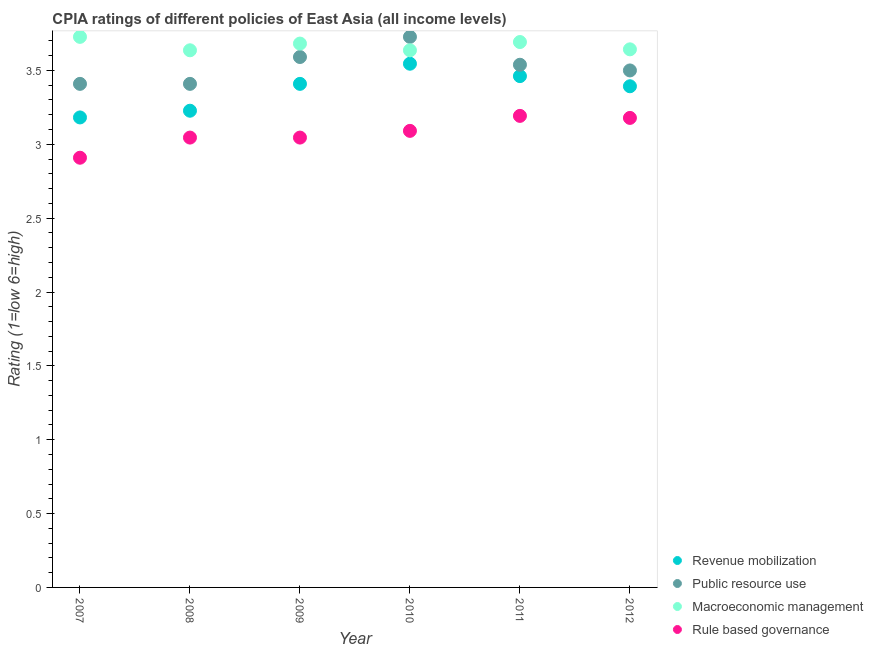How many different coloured dotlines are there?
Keep it short and to the point. 4. Across all years, what is the maximum cpia rating of revenue mobilization?
Ensure brevity in your answer.  3.55. Across all years, what is the minimum cpia rating of macroeconomic management?
Ensure brevity in your answer.  3.64. What is the total cpia rating of public resource use in the graph?
Your answer should be very brief. 21.17. What is the difference between the cpia rating of revenue mobilization in 2007 and that in 2010?
Provide a succinct answer. -0.36. What is the difference between the cpia rating of macroeconomic management in 2010 and the cpia rating of revenue mobilization in 2009?
Your answer should be compact. 0.23. What is the average cpia rating of rule based governance per year?
Ensure brevity in your answer.  3.08. In the year 2012, what is the difference between the cpia rating of rule based governance and cpia rating of macroeconomic management?
Ensure brevity in your answer.  -0.46. In how many years, is the cpia rating of rule based governance greater than 0.9?
Provide a short and direct response. 6. What is the ratio of the cpia rating of rule based governance in 2010 to that in 2011?
Keep it short and to the point. 0.97. Is the cpia rating of rule based governance in 2008 less than that in 2010?
Ensure brevity in your answer.  Yes. What is the difference between the highest and the second highest cpia rating of macroeconomic management?
Your answer should be very brief. 0.03. What is the difference between the highest and the lowest cpia rating of public resource use?
Offer a very short reply. 0.32. Is it the case that in every year, the sum of the cpia rating of rule based governance and cpia rating of revenue mobilization is greater than the sum of cpia rating of public resource use and cpia rating of macroeconomic management?
Provide a succinct answer. No. Is the cpia rating of public resource use strictly greater than the cpia rating of revenue mobilization over the years?
Give a very brief answer. Yes. Is the cpia rating of macroeconomic management strictly less than the cpia rating of revenue mobilization over the years?
Provide a short and direct response. No. How many dotlines are there?
Provide a succinct answer. 4. How many years are there in the graph?
Your answer should be very brief. 6. What is the difference between two consecutive major ticks on the Y-axis?
Give a very brief answer. 0.5. Does the graph contain any zero values?
Provide a succinct answer. No. Where does the legend appear in the graph?
Your answer should be compact. Bottom right. What is the title of the graph?
Make the answer very short. CPIA ratings of different policies of East Asia (all income levels). Does "Compensation of employees" appear as one of the legend labels in the graph?
Make the answer very short. No. What is the label or title of the X-axis?
Offer a very short reply. Year. What is the label or title of the Y-axis?
Give a very brief answer. Rating (1=low 6=high). What is the Rating (1=low 6=high) of Revenue mobilization in 2007?
Provide a succinct answer. 3.18. What is the Rating (1=low 6=high) of Public resource use in 2007?
Give a very brief answer. 3.41. What is the Rating (1=low 6=high) in Macroeconomic management in 2007?
Keep it short and to the point. 3.73. What is the Rating (1=low 6=high) in Rule based governance in 2007?
Offer a very short reply. 2.91. What is the Rating (1=low 6=high) in Revenue mobilization in 2008?
Keep it short and to the point. 3.23. What is the Rating (1=low 6=high) in Public resource use in 2008?
Your answer should be compact. 3.41. What is the Rating (1=low 6=high) in Macroeconomic management in 2008?
Provide a short and direct response. 3.64. What is the Rating (1=low 6=high) in Rule based governance in 2008?
Give a very brief answer. 3.05. What is the Rating (1=low 6=high) in Revenue mobilization in 2009?
Keep it short and to the point. 3.41. What is the Rating (1=low 6=high) in Public resource use in 2009?
Ensure brevity in your answer.  3.59. What is the Rating (1=low 6=high) of Macroeconomic management in 2009?
Give a very brief answer. 3.68. What is the Rating (1=low 6=high) of Rule based governance in 2009?
Make the answer very short. 3.05. What is the Rating (1=low 6=high) in Revenue mobilization in 2010?
Your answer should be very brief. 3.55. What is the Rating (1=low 6=high) in Public resource use in 2010?
Provide a short and direct response. 3.73. What is the Rating (1=low 6=high) of Macroeconomic management in 2010?
Give a very brief answer. 3.64. What is the Rating (1=low 6=high) of Rule based governance in 2010?
Make the answer very short. 3.09. What is the Rating (1=low 6=high) in Revenue mobilization in 2011?
Ensure brevity in your answer.  3.46. What is the Rating (1=low 6=high) in Public resource use in 2011?
Provide a short and direct response. 3.54. What is the Rating (1=low 6=high) in Macroeconomic management in 2011?
Offer a terse response. 3.69. What is the Rating (1=low 6=high) of Rule based governance in 2011?
Your answer should be very brief. 3.19. What is the Rating (1=low 6=high) of Revenue mobilization in 2012?
Provide a succinct answer. 3.39. What is the Rating (1=low 6=high) in Macroeconomic management in 2012?
Your answer should be compact. 3.64. What is the Rating (1=low 6=high) in Rule based governance in 2012?
Provide a short and direct response. 3.18. Across all years, what is the maximum Rating (1=low 6=high) of Revenue mobilization?
Your answer should be compact. 3.55. Across all years, what is the maximum Rating (1=low 6=high) in Public resource use?
Give a very brief answer. 3.73. Across all years, what is the maximum Rating (1=low 6=high) in Macroeconomic management?
Provide a succinct answer. 3.73. Across all years, what is the maximum Rating (1=low 6=high) in Rule based governance?
Keep it short and to the point. 3.19. Across all years, what is the minimum Rating (1=low 6=high) of Revenue mobilization?
Provide a short and direct response. 3.18. Across all years, what is the minimum Rating (1=low 6=high) of Public resource use?
Offer a very short reply. 3.41. Across all years, what is the minimum Rating (1=low 6=high) of Macroeconomic management?
Give a very brief answer. 3.64. Across all years, what is the minimum Rating (1=low 6=high) in Rule based governance?
Offer a very short reply. 2.91. What is the total Rating (1=low 6=high) of Revenue mobilization in the graph?
Make the answer very short. 20.22. What is the total Rating (1=low 6=high) in Public resource use in the graph?
Your answer should be very brief. 21.17. What is the total Rating (1=low 6=high) in Macroeconomic management in the graph?
Your answer should be very brief. 22.02. What is the total Rating (1=low 6=high) of Rule based governance in the graph?
Your response must be concise. 18.46. What is the difference between the Rating (1=low 6=high) in Revenue mobilization in 2007 and that in 2008?
Provide a short and direct response. -0.05. What is the difference between the Rating (1=low 6=high) in Public resource use in 2007 and that in 2008?
Make the answer very short. 0. What is the difference between the Rating (1=low 6=high) in Macroeconomic management in 2007 and that in 2008?
Your answer should be compact. 0.09. What is the difference between the Rating (1=low 6=high) in Rule based governance in 2007 and that in 2008?
Your response must be concise. -0.14. What is the difference between the Rating (1=low 6=high) of Revenue mobilization in 2007 and that in 2009?
Provide a short and direct response. -0.23. What is the difference between the Rating (1=low 6=high) in Public resource use in 2007 and that in 2009?
Your response must be concise. -0.18. What is the difference between the Rating (1=low 6=high) in Macroeconomic management in 2007 and that in 2009?
Your answer should be very brief. 0.05. What is the difference between the Rating (1=low 6=high) in Rule based governance in 2007 and that in 2009?
Your answer should be compact. -0.14. What is the difference between the Rating (1=low 6=high) of Revenue mobilization in 2007 and that in 2010?
Offer a very short reply. -0.36. What is the difference between the Rating (1=low 6=high) in Public resource use in 2007 and that in 2010?
Ensure brevity in your answer.  -0.32. What is the difference between the Rating (1=low 6=high) of Macroeconomic management in 2007 and that in 2010?
Offer a very short reply. 0.09. What is the difference between the Rating (1=low 6=high) of Rule based governance in 2007 and that in 2010?
Your answer should be compact. -0.18. What is the difference between the Rating (1=low 6=high) in Revenue mobilization in 2007 and that in 2011?
Give a very brief answer. -0.28. What is the difference between the Rating (1=low 6=high) of Public resource use in 2007 and that in 2011?
Your response must be concise. -0.13. What is the difference between the Rating (1=low 6=high) in Macroeconomic management in 2007 and that in 2011?
Your answer should be very brief. 0.04. What is the difference between the Rating (1=low 6=high) of Rule based governance in 2007 and that in 2011?
Offer a terse response. -0.28. What is the difference between the Rating (1=low 6=high) in Revenue mobilization in 2007 and that in 2012?
Give a very brief answer. -0.21. What is the difference between the Rating (1=low 6=high) of Public resource use in 2007 and that in 2012?
Make the answer very short. -0.09. What is the difference between the Rating (1=low 6=high) of Macroeconomic management in 2007 and that in 2012?
Give a very brief answer. 0.08. What is the difference between the Rating (1=low 6=high) of Rule based governance in 2007 and that in 2012?
Keep it short and to the point. -0.27. What is the difference between the Rating (1=low 6=high) in Revenue mobilization in 2008 and that in 2009?
Your answer should be very brief. -0.18. What is the difference between the Rating (1=low 6=high) in Public resource use in 2008 and that in 2009?
Make the answer very short. -0.18. What is the difference between the Rating (1=low 6=high) in Macroeconomic management in 2008 and that in 2009?
Provide a succinct answer. -0.05. What is the difference between the Rating (1=low 6=high) of Rule based governance in 2008 and that in 2009?
Your response must be concise. 0. What is the difference between the Rating (1=low 6=high) of Revenue mobilization in 2008 and that in 2010?
Your answer should be very brief. -0.32. What is the difference between the Rating (1=low 6=high) in Public resource use in 2008 and that in 2010?
Your response must be concise. -0.32. What is the difference between the Rating (1=low 6=high) in Rule based governance in 2008 and that in 2010?
Keep it short and to the point. -0.05. What is the difference between the Rating (1=low 6=high) in Revenue mobilization in 2008 and that in 2011?
Your answer should be compact. -0.23. What is the difference between the Rating (1=low 6=high) in Public resource use in 2008 and that in 2011?
Give a very brief answer. -0.13. What is the difference between the Rating (1=low 6=high) in Macroeconomic management in 2008 and that in 2011?
Offer a very short reply. -0.06. What is the difference between the Rating (1=low 6=high) of Rule based governance in 2008 and that in 2011?
Your answer should be compact. -0.15. What is the difference between the Rating (1=low 6=high) in Revenue mobilization in 2008 and that in 2012?
Your response must be concise. -0.17. What is the difference between the Rating (1=low 6=high) of Public resource use in 2008 and that in 2012?
Provide a short and direct response. -0.09. What is the difference between the Rating (1=low 6=high) of Macroeconomic management in 2008 and that in 2012?
Give a very brief answer. -0.01. What is the difference between the Rating (1=low 6=high) of Rule based governance in 2008 and that in 2012?
Ensure brevity in your answer.  -0.13. What is the difference between the Rating (1=low 6=high) in Revenue mobilization in 2009 and that in 2010?
Your response must be concise. -0.14. What is the difference between the Rating (1=low 6=high) of Public resource use in 2009 and that in 2010?
Provide a short and direct response. -0.14. What is the difference between the Rating (1=low 6=high) in Macroeconomic management in 2009 and that in 2010?
Keep it short and to the point. 0.05. What is the difference between the Rating (1=low 6=high) of Rule based governance in 2009 and that in 2010?
Ensure brevity in your answer.  -0.05. What is the difference between the Rating (1=low 6=high) in Revenue mobilization in 2009 and that in 2011?
Ensure brevity in your answer.  -0.05. What is the difference between the Rating (1=low 6=high) in Public resource use in 2009 and that in 2011?
Make the answer very short. 0.05. What is the difference between the Rating (1=low 6=high) of Macroeconomic management in 2009 and that in 2011?
Provide a short and direct response. -0.01. What is the difference between the Rating (1=low 6=high) of Rule based governance in 2009 and that in 2011?
Your response must be concise. -0.15. What is the difference between the Rating (1=low 6=high) in Revenue mobilization in 2009 and that in 2012?
Offer a terse response. 0.02. What is the difference between the Rating (1=low 6=high) in Public resource use in 2009 and that in 2012?
Provide a succinct answer. 0.09. What is the difference between the Rating (1=low 6=high) of Macroeconomic management in 2009 and that in 2012?
Your answer should be very brief. 0.04. What is the difference between the Rating (1=low 6=high) in Rule based governance in 2009 and that in 2012?
Provide a succinct answer. -0.13. What is the difference between the Rating (1=low 6=high) of Revenue mobilization in 2010 and that in 2011?
Offer a terse response. 0.08. What is the difference between the Rating (1=low 6=high) in Public resource use in 2010 and that in 2011?
Ensure brevity in your answer.  0.19. What is the difference between the Rating (1=low 6=high) of Macroeconomic management in 2010 and that in 2011?
Ensure brevity in your answer.  -0.06. What is the difference between the Rating (1=low 6=high) of Rule based governance in 2010 and that in 2011?
Provide a short and direct response. -0.1. What is the difference between the Rating (1=low 6=high) of Revenue mobilization in 2010 and that in 2012?
Keep it short and to the point. 0.15. What is the difference between the Rating (1=low 6=high) in Public resource use in 2010 and that in 2012?
Your answer should be compact. 0.23. What is the difference between the Rating (1=low 6=high) in Macroeconomic management in 2010 and that in 2012?
Your answer should be compact. -0.01. What is the difference between the Rating (1=low 6=high) in Rule based governance in 2010 and that in 2012?
Your response must be concise. -0.09. What is the difference between the Rating (1=low 6=high) in Revenue mobilization in 2011 and that in 2012?
Provide a succinct answer. 0.07. What is the difference between the Rating (1=low 6=high) in Public resource use in 2011 and that in 2012?
Your answer should be compact. 0.04. What is the difference between the Rating (1=low 6=high) of Macroeconomic management in 2011 and that in 2012?
Provide a succinct answer. 0.05. What is the difference between the Rating (1=low 6=high) of Rule based governance in 2011 and that in 2012?
Offer a terse response. 0.01. What is the difference between the Rating (1=low 6=high) of Revenue mobilization in 2007 and the Rating (1=low 6=high) of Public resource use in 2008?
Make the answer very short. -0.23. What is the difference between the Rating (1=low 6=high) of Revenue mobilization in 2007 and the Rating (1=low 6=high) of Macroeconomic management in 2008?
Your answer should be very brief. -0.45. What is the difference between the Rating (1=low 6=high) of Revenue mobilization in 2007 and the Rating (1=low 6=high) of Rule based governance in 2008?
Your answer should be compact. 0.14. What is the difference between the Rating (1=low 6=high) in Public resource use in 2007 and the Rating (1=low 6=high) in Macroeconomic management in 2008?
Your answer should be very brief. -0.23. What is the difference between the Rating (1=low 6=high) in Public resource use in 2007 and the Rating (1=low 6=high) in Rule based governance in 2008?
Keep it short and to the point. 0.36. What is the difference between the Rating (1=low 6=high) of Macroeconomic management in 2007 and the Rating (1=low 6=high) of Rule based governance in 2008?
Offer a terse response. 0.68. What is the difference between the Rating (1=low 6=high) in Revenue mobilization in 2007 and the Rating (1=low 6=high) in Public resource use in 2009?
Ensure brevity in your answer.  -0.41. What is the difference between the Rating (1=low 6=high) in Revenue mobilization in 2007 and the Rating (1=low 6=high) in Macroeconomic management in 2009?
Give a very brief answer. -0.5. What is the difference between the Rating (1=low 6=high) of Revenue mobilization in 2007 and the Rating (1=low 6=high) of Rule based governance in 2009?
Ensure brevity in your answer.  0.14. What is the difference between the Rating (1=low 6=high) in Public resource use in 2007 and the Rating (1=low 6=high) in Macroeconomic management in 2009?
Your answer should be very brief. -0.27. What is the difference between the Rating (1=low 6=high) of Public resource use in 2007 and the Rating (1=low 6=high) of Rule based governance in 2009?
Ensure brevity in your answer.  0.36. What is the difference between the Rating (1=low 6=high) of Macroeconomic management in 2007 and the Rating (1=low 6=high) of Rule based governance in 2009?
Your response must be concise. 0.68. What is the difference between the Rating (1=low 6=high) in Revenue mobilization in 2007 and the Rating (1=low 6=high) in Public resource use in 2010?
Your answer should be compact. -0.55. What is the difference between the Rating (1=low 6=high) of Revenue mobilization in 2007 and the Rating (1=low 6=high) of Macroeconomic management in 2010?
Ensure brevity in your answer.  -0.45. What is the difference between the Rating (1=low 6=high) of Revenue mobilization in 2007 and the Rating (1=low 6=high) of Rule based governance in 2010?
Make the answer very short. 0.09. What is the difference between the Rating (1=low 6=high) of Public resource use in 2007 and the Rating (1=low 6=high) of Macroeconomic management in 2010?
Provide a short and direct response. -0.23. What is the difference between the Rating (1=low 6=high) in Public resource use in 2007 and the Rating (1=low 6=high) in Rule based governance in 2010?
Provide a short and direct response. 0.32. What is the difference between the Rating (1=low 6=high) of Macroeconomic management in 2007 and the Rating (1=low 6=high) of Rule based governance in 2010?
Ensure brevity in your answer.  0.64. What is the difference between the Rating (1=low 6=high) of Revenue mobilization in 2007 and the Rating (1=low 6=high) of Public resource use in 2011?
Offer a very short reply. -0.36. What is the difference between the Rating (1=low 6=high) of Revenue mobilization in 2007 and the Rating (1=low 6=high) of Macroeconomic management in 2011?
Provide a succinct answer. -0.51. What is the difference between the Rating (1=low 6=high) of Revenue mobilization in 2007 and the Rating (1=low 6=high) of Rule based governance in 2011?
Make the answer very short. -0.01. What is the difference between the Rating (1=low 6=high) in Public resource use in 2007 and the Rating (1=low 6=high) in Macroeconomic management in 2011?
Offer a very short reply. -0.28. What is the difference between the Rating (1=low 6=high) in Public resource use in 2007 and the Rating (1=low 6=high) in Rule based governance in 2011?
Your response must be concise. 0.22. What is the difference between the Rating (1=low 6=high) in Macroeconomic management in 2007 and the Rating (1=low 6=high) in Rule based governance in 2011?
Provide a succinct answer. 0.54. What is the difference between the Rating (1=low 6=high) of Revenue mobilization in 2007 and the Rating (1=low 6=high) of Public resource use in 2012?
Provide a short and direct response. -0.32. What is the difference between the Rating (1=low 6=high) in Revenue mobilization in 2007 and the Rating (1=low 6=high) in Macroeconomic management in 2012?
Ensure brevity in your answer.  -0.46. What is the difference between the Rating (1=low 6=high) in Revenue mobilization in 2007 and the Rating (1=low 6=high) in Rule based governance in 2012?
Your answer should be compact. 0. What is the difference between the Rating (1=low 6=high) in Public resource use in 2007 and the Rating (1=low 6=high) in Macroeconomic management in 2012?
Give a very brief answer. -0.23. What is the difference between the Rating (1=low 6=high) in Public resource use in 2007 and the Rating (1=low 6=high) in Rule based governance in 2012?
Ensure brevity in your answer.  0.23. What is the difference between the Rating (1=low 6=high) in Macroeconomic management in 2007 and the Rating (1=low 6=high) in Rule based governance in 2012?
Provide a succinct answer. 0.55. What is the difference between the Rating (1=low 6=high) of Revenue mobilization in 2008 and the Rating (1=low 6=high) of Public resource use in 2009?
Make the answer very short. -0.36. What is the difference between the Rating (1=low 6=high) of Revenue mobilization in 2008 and the Rating (1=low 6=high) of Macroeconomic management in 2009?
Keep it short and to the point. -0.45. What is the difference between the Rating (1=low 6=high) of Revenue mobilization in 2008 and the Rating (1=low 6=high) of Rule based governance in 2009?
Your answer should be very brief. 0.18. What is the difference between the Rating (1=low 6=high) of Public resource use in 2008 and the Rating (1=low 6=high) of Macroeconomic management in 2009?
Keep it short and to the point. -0.27. What is the difference between the Rating (1=low 6=high) of Public resource use in 2008 and the Rating (1=low 6=high) of Rule based governance in 2009?
Offer a very short reply. 0.36. What is the difference between the Rating (1=low 6=high) of Macroeconomic management in 2008 and the Rating (1=low 6=high) of Rule based governance in 2009?
Your response must be concise. 0.59. What is the difference between the Rating (1=low 6=high) of Revenue mobilization in 2008 and the Rating (1=low 6=high) of Macroeconomic management in 2010?
Ensure brevity in your answer.  -0.41. What is the difference between the Rating (1=low 6=high) of Revenue mobilization in 2008 and the Rating (1=low 6=high) of Rule based governance in 2010?
Your answer should be compact. 0.14. What is the difference between the Rating (1=low 6=high) in Public resource use in 2008 and the Rating (1=low 6=high) in Macroeconomic management in 2010?
Offer a terse response. -0.23. What is the difference between the Rating (1=low 6=high) of Public resource use in 2008 and the Rating (1=low 6=high) of Rule based governance in 2010?
Your answer should be compact. 0.32. What is the difference between the Rating (1=low 6=high) of Macroeconomic management in 2008 and the Rating (1=low 6=high) of Rule based governance in 2010?
Make the answer very short. 0.55. What is the difference between the Rating (1=low 6=high) of Revenue mobilization in 2008 and the Rating (1=low 6=high) of Public resource use in 2011?
Give a very brief answer. -0.31. What is the difference between the Rating (1=low 6=high) of Revenue mobilization in 2008 and the Rating (1=low 6=high) of Macroeconomic management in 2011?
Make the answer very short. -0.47. What is the difference between the Rating (1=low 6=high) of Revenue mobilization in 2008 and the Rating (1=low 6=high) of Rule based governance in 2011?
Ensure brevity in your answer.  0.04. What is the difference between the Rating (1=low 6=high) in Public resource use in 2008 and the Rating (1=low 6=high) in Macroeconomic management in 2011?
Provide a succinct answer. -0.28. What is the difference between the Rating (1=low 6=high) in Public resource use in 2008 and the Rating (1=low 6=high) in Rule based governance in 2011?
Keep it short and to the point. 0.22. What is the difference between the Rating (1=low 6=high) in Macroeconomic management in 2008 and the Rating (1=low 6=high) in Rule based governance in 2011?
Offer a very short reply. 0.44. What is the difference between the Rating (1=low 6=high) of Revenue mobilization in 2008 and the Rating (1=low 6=high) of Public resource use in 2012?
Your answer should be compact. -0.27. What is the difference between the Rating (1=low 6=high) of Revenue mobilization in 2008 and the Rating (1=low 6=high) of Macroeconomic management in 2012?
Your response must be concise. -0.42. What is the difference between the Rating (1=low 6=high) of Revenue mobilization in 2008 and the Rating (1=low 6=high) of Rule based governance in 2012?
Your answer should be compact. 0.05. What is the difference between the Rating (1=low 6=high) in Public resource use in 2008 and the Rating (1=low 6=high) in Macroeconomic management in 2012?
Your answer should be compact. -0.23. What is the difference between the Rating (1=low 6=high) in Public resource use in 2008 and the Rating (1=low 6=high) in Rule based governance in 2012?
Offer a terse response. 0.23. What is the difference between the Rating (1=low 6=high) of Macroeconomic management in 2008 and the Rating (1=low 6=high) of Rule based governance in 2012?
Keep it short and to the point. 0.46. What is the difference between the Rating (1=low 6=high) in Revenue mobilization in 2009 and the Rating (1=low 6=high) in Public resource use in 2010?
Your answer should be very brief. -0.32. What is the difference between the Rating (1=low 6=high) in Revenue mobilization in 2009 and the Rating (1=low 6=high) in Macroeconomic management in 2010?
Make the answer very short. -0.23. What is the difference between the Rating (1=low 6=high) in Revenue mobilization in 2009 and the Rating (1=low 6=high) in Rule based governance in 2010?
Offer a terse response. 0.32. What is the difference between the Rating (1=low 6=high) in Public resource use in 2009 and the Rating (1=low 6=high) in Macroeconomic management in 2010?
Make the answer very short. -0.05. What is the difference between the Rating (1=low 6=high) in Macroeconomic management in 2009 and the Rating (1=low 6=high) in Rule based governance in 2010?
Your answer should be compact. 0.59. What is the difference between the Rating (1=low 6=high) in Revenue mobilization in 2009 and the Rating (1=low 6=high) in Public resource use in 2011?
Your answer should be compact. -0.13. What is the difference between the Rating (1=low 6=high) of Revenue mobilization in 2009 and the Rating (1=low 6=high) of Macroeconomic management in 2011?
Your response must be concise. -0.28. What is the difference between the Rating (1=low 6=high) in Revenue mobilization in 2009 and the Rating (1=low 6=high) in Rule based governance in 2011?
Your answer should be compact. 0.22. What is the difference between the Rating (1=low 6=high) in Public resource use in 2009 and the Rating (1=low 6=high) in Macroeconomic management in 2011?
Keep it short and to the point. -0.1. What is the difference between the Rating (1=low 6=high) in Public resource use in 2009 and the Rating (1=low 6=high) in Rule based governance in 2011?
Provide a succinct answer. 0.4. What is the difference between the Rating (1=low 6=high) in Macroeconomic management in 2009 and the Rating (1=low 6=high) in Rule based governance in 2011?
Ensure brevity in your answer.  0.49. What is the difference between the Rating (1=low 6=high) of Revenue mobilization in 2009 and the Rating (1=low 6=high) of Public resource use in 2012?
Offer a very short reply. -0.09. What is the difference between the Rating (1=low 6=high) in Revenue mobilization in 2009 and the Rating (1=low 6=high) in Macroeconomic management in 2012?
Give a very brief answer. -0.23. What is the difference between the Rating (1=low 6=high) in Revenue mobilization in 2009 and the Rating (1=low 6=high) in Rule based governance in 2012?
Make the answer very short. 0.23. What is the difference between the Rating (1=low 6=high) in Public resource use in 2009 and the Rating (1=low 6=high) in Macroeconomic management in 2012?
Make the answer very short. -0.05. What is the difference between the Rating (1=low 6=high) in Public resource use in 2009 and the Rating (1=low 6=high) in Rule based governance in 2012?
Provide a succinct answer. 0.41. What is the difference between the Rating (1=low 6=high) of Macroeconomic management in 2009 and the Rating (1=low 6=high) of Rule based governance in 2012?
Your answer should be very brief. 0.5. What is the difference between the Rating (1=low 6=high) in Revenue mobilization in 2010 and the Rating (1=low 6=high) in Public resource use in 2011?
Offer a very short reply. 0.01. What is the difference between the Rating (1=low 6=high) of Revenue mobilization in 2010 and the Rating (1=low 6=high) of Macroeconomic management in 2011?
Offer a terse response. -0.15. What is the difference between the Rating (1=low 6=high) in Revenue mobilization in 2010 and the Rating (1=low 6=high) in Rule based governance in 2011?
Ensure brevity in your answer.  0.35. What is the difference between the Rating (1=low 6=high) of Public resource use in 2010 and the Rating (1=low 6=high) of Macroeconomic management in 2011?
Keep it short and to the point. 0.04. What is the difference between the Rating (1=low 6=high) in Public resource use in 2010 and the Rating (1=low 6=high) in Rule based governance in 2011?
Offer a terse response. 0.54. What is the difference between the Rating (1=low 6=high) in Macroeconomic management in 2010 and the Rating (1=low 6=high) in Rule based governance in 2011?
Provide a short and direct response. 0.44. What is the difference between the Rating (1=low 6=high) of Revenue mobilization in 2010 and the Rating (1=low 6=high) of Public resource use in 2012?
Make the answer very short. 0.05. What is the difference between the Rating (1=low 6=high) of Revenue mobilization in 2010 and the Rating (1=low 6=high) of Macroeconomic management in 2012?
Make the answer very short. -0.1. What is the difference between the Rating (1=low 6=high) of Revenue mobilization in 2010 and the Rating (1=low 6=high) of Rule based governance in 2012?
Make the answer very short. 0.37. What is the difference between the Rating (1=low 6=high) in Public resource use in 2010 and the Rating (1=low 6=high) in Macroeconomic management in 2012?
Make the answer very short. 0.08. What is the difference between the Rating (1=low 6=high) in Public resource use in 2010 and the Rating (1=low 6=high) in Rule based governance in 2012?
Ensure brevity in your answer.  0.55. What is the difference between the Rating (1=low 6=high) in Macroeconomic management in 2010 and the Rating (1=low 6=high) in Rule based governance in 2012?
Provide a succinct answer. 0.46. What is the difference between the Rating (1=low 6=high) in Revenue mobilization in 2011 and the Rating (1=low 6=high) in Public resource use in 2012?
Make the answer very short. -0.04. What is the difference between the Rating (1=low 6=high) of Revenue mobilization in 2011 and the Rating (1=low 6=high) of Macroeconomic management in 2012?
Your answer should be compact. -0.18. What is the difference between the Rating (1=low 6=high) of Revenue mobilization in 2011 and the Rating (1=low 6=high) of Rule based governance in 2012?
Ensure brevity in your answer.  0.28. What is the difference between the Rating (1=low 6=high) of Public resource use in 2011 and the Rating (1=low 6=high) of Macroeconomic management in 2012?
Your answer should be compact. -0.1. What is the difference between the Rating (1=low 6=high) of Public resource use in 2011 and the Rating (1=low 6=high) of Rule based governance in 2012?
Offer a very short reply. 0.36. What is the difference between the Rating (1=low 6=high) of Macroeconomic management in 2011 and the Rating (1=low 6=high) of Rule based governance in 2012?
Provide a succinct answer. 0.51. What is the average Rating (1=low 6=high) in Revenue mobilization per year?
Ensure brevity in your answer.  3.37. What is the average Rating (1=low 6=high) in Public resource use per year?
Provide a short and direct response. 3.53. What is the average Rating (1=low 6=high) in Macroeconomic management per year?
Offer a terse response. 3.67. What is the average Rating (1=low 6=high) of Rule based governance per year?
Ensure brevity in your answer.  3.08. In the year 2007, what is the difference between the Rating (1=low 6=high) of Revenue mobilization and Rating (1=low 6=high) of Public resource use?
Make the answer very short. -0.23. In the year 2007, what is the difference between the Rating (1=low 6=high) of Revenue mobilization and Rating (1=low 6=high) of Macroeconomic management?
Ensure brevity in your answer.  -0.55. In the year 2007, what is the difference between the Rating (1=low 6=high) in Revenue mobilization and Rating (1=low 6=high) in Rule based governance?
Make the answer very short. 0.27. In the year 2007, what is the difference between the Rating (1=low 6=high) of Public resource use and Rating (1=low 6=high) of Macroeconomic management?
Ensure brevity in your answer.  -0.32. In the year 2007, what is the difference between the Rating (1=low 6=high) of Public resource use and Rating (1=low 6=high) of Rule based governance?
Keep it short and to the point. 0.5. In the year 2007, what is the difference between the Rating (1=low 6=high) in Macroeconomic management and Rating (1=low 6=high) in Rule based governance?
Offer a terse response. 0.82. In the year 2008, what is the difference between the Rating (1=low 6=high) of Revenue mobilization and Rating (1=low 6=high) of Public resource use?
Offer a terse response. -0.18. In the year 2008, what is the difference between the Rating (1=low 6=high) of Revenue mobilization and Rating (1=low 6=high) of Macroeconomic management?
Give a very brief answer. -0.41. In the year 2008, what is the difference between the Rating (1=low 6=high) of Revenue mobilization and Rating (1=low 6=high) of Rule based governance?
Offer a very short reply. 0.18. In the year 2008, what is the difference between the Rating (1=low 6=high) in Public resource use and Rating (1=low 6=high) in Macroeconomic management?
Ensure brevity in your answer.  -0.23. In the year 2008, what is the difference between the Rating (1=low 6=high) in Public resource use and Rating (1=low 6=high) in Rule based governance?
Offer a terse response. 0.36. In the year 2008, what is the difference between the Rating (1=low 6=high) of Macroeconomic management and Rating (1=low 6=high) of Rule based governance?
Ensure brevity in your answer.  0.59. In the year 2009, what is the difference between the Rating (1=low 6=high) of Revenue mobilization and Rating (1=low 6=high) of Public resource use?
Your answer should be very brief. -0.18. In the year 2009, what is the difference between the Rating (1=low 6=high) in Revenue mobilization and Rating (1=low 6=high) in Macroeconomic management?
Your answer should be very brief. -0.27. In the year 2009, what is the difference between the Rating (1=low 6=high) in Revenue mobilization and Rating (1=low 6=high) in Rule based governance?
Keep it short and to the point. 0.36. In the year 2009, what is the difference between the Rating (1=low 6=high) of Public resource use and Rating (1=low 6=high) of Macroeconomic management?
Give a very brief answer. -0.09. In the year 2009, what is the difference between the Rating (1=low 6=high) of Public resource use and Rating (1=low 6=high) of Rule based governance?
Provide a short and direct response. 0.55. In the year 2009, what is the difference between the Rating (1=low 6=high) in Macroeconomic management and Rating (1=low 6=high) in Rule based governance?
Your answer should be very brief. 0.64. In the year 2010, what is the difference between the Rating (1=low 6=high) of Revenue mobilization and Rating (1=low 6=high) of Public resource use?
Offer a terse response. -0.18. In the year 2010, what is the difference between the Rating (1=low 6=high) of Revenue mobilization and Rating (1=low 6=high) of Macroeconomic management?
Keep it short and to the point. -0.09. In the year 2010, what is the difference between the Rating (1=low 6=high) of Revenue mobilization and Rating (1=low 6=high) of Rule based governance?
Keep it short and to the point. 0.45. In the year 2010, what is the difference between the Rating (1=low 6=high) of Public resource use and Rating (1=low 6=high) of Macroeconomic management?
Provide a succinct answer. 0.09. In the year 2010, what is the difference between the Rating (1=low 6=high) of Public resource use and Rating (1=low 6=high) of Rule based governance?
Give a very brief answer. 0.64. In the year 2010, what is the difference between the Rating (1=low 6=high) in Macroeconomic management and Rating (1=low 6=high) in Rule based governance?
Offer a terse response. 0.55. In the year 2011, what is the difference between the Rating (1=low 6=high) in Revenue mobilization and Rating (1=low 6=high) in Public resource use?
Your response must be concise. -0.08. In the year 2011, what is the difference between the Rating (1=low 6=high) of Revenue mobilization and Rating (1=low 6=high) of Macroeconomic management?
Offer a terse response. -0.23. In the year 2011, what is the difference between the Rating (1=low 6=high) of Revenue mobilization and Rating (1=low 6=high) of Rule based governance?
Offer a very short reply. 0.27. In the year 2011, what is the difference between the Rating (1=low 6=high) of Public resource use and Rating (1=low 6=high) of Macroeconomic management?
Give a very brief answer. -0.15. In the year 2011, what is the difference between the Rating (1=low 6=high) in Public resource use and Rating (1=low 6=high) in Rule based governance?
Provide a succinct answer. 0.35. In the year 2012, what is the difference between the Rating (1=low 6=high) of Revenue mobilization and Rating (1=low 6=high) of Public resource use?
Make the answer very short. -0.11. In the year 2012, what is the difference between the Rating (1=low 6=high) of Revenue mobilization and Rating (1=low 6=high) of Rule based governance?
Give a very brief answer. 0.21. In the year 2012, what is the difference between the Rating (1=low 6=high) in Public resource use and Rating (1=low 6=high) in Macroeconomic management?
Your answer should be very brief. -0.14. In the year 2012, what is the difference between the Rating (1=low 6=high) of Public resource use and Rating (1=low 6=high) of Rule based governance?
Your answer should be very brief. 0.32. In the year 2012, what is the difference between the Rating (1=low 6=high) of Macroeconomic management and Rating (1=low 6=high) of Rule based governance?
Provide a succinct answer. 0.46. What is the ratio of the Rating (1=low 6=high) of Revenue mobilization in 2007 to that in 2008?
Offer a terse response. 0.99. What is the ratio of the Rating (1=low 6=high) of Public resource use in 2007 to that in 2008?
Provide a succinct answer. 1. What is the ratio of the Rating (1=low 6=high) in Macroeconomic management in 2007 to that in 2008?
Offer a very short reply. 1.02. What is the ratio of the Rating (1=low 6=high) in Rule based governance in 2007 to that in 2008?
Your response must be concise. 0.96. What is the ratio of the Rating (1=low 6=high) of Public resource use in 2007 to that in 2009?
Offer a very short reply. 0.95. What is the ratio of the Rating (1=low 6=high) of Macroeconomic management in 2007 to that in 2009?
Your answer should be very brief. 1.01. What is the ratio of the Rating (1=low 6=high) in Rule based governance in 2007 to that in 2009?
Ensure brevity in your answer.  0.96. What is the ratio of the Rating (1=low 6=high) in Revenue mobilization in 2007 to that in 2010?
Provide a short and direct response. 0.9. What is the ratio of the Rating (1=low 6=high) of Public resource use in 2007 to that in 2010?
Provide a succinct answer. 0.91. What is the ratio of the Rating (1=low 6=high) in Macroeconomic management in 2007 to that in 2010?
Offer a terse response. 1.02. What is the ratio of the Rating (1=low 6=high) in Revenue mobilization in 2007 to that in 2011?
Keep it short and to the point. 0.92. What is the ratio of the Rating (1=low 6=high) of Public resource use in 2007 to that in 2011?
Provide a succinct answer. 0.96. What is the ratio of the Rating (1=low 6=high) of Macroeconomic management in 2007 to that in 2011?
Ensure brevity in your answer.  1.01. What is the ratio of the Rating (1=low 6=high) of Rule based governance in 2007 to that in 2011?
Ensure brevity in your answer.  0.91. What is the ratio of the Rating (1=low 6=high) of Revenue mobilization in 2007 to that in 2012?
Provide a short and direct response. 0.94. What is the ratio of the Rating (1=low 6=high) of Macroeconomic management in 2007 to that in 2012?
Make the answer very short. 1.02. What is the ratio of the Rating (1=low 6=high) of Rule based governance in 2007 to that in 2012?
Offer a very short reply. 0.92. What is the ratio of the Rating (1=low 6=high) of Revenue mobilization in 2008 to that in 2009?
Give a very brief answer. 0.95. What is the ratio of the Rating (1=low 6=high) of Public resource use in 2008 to that in 2009?
Offer a terse response. 0.95. What is the ratio of the Rating (1=low 6=high) of Macroeconomic management in 2008 to that in 2009?
Offer a terse response. 0.99. What is the ratio of the Rating (1=low 6=high) in Revenue mobilization in 2008 to that in 2010?
Your response must be concise. 0.91. What is the ratio of the Rating (1=low 6=high) of Public resource use in 2008 to that in 2010?
Offer a very short reply. 0.91. What is the ratio of the Rating (1=low 6=high) of Rule based governance in 2008 to that in 2010?
Ensure brevity in your answer.  0.99. What is the ratio of the Rating (1=low 6=high) in Revenue mobilization in 2008 to that in 2011?
Offer a terse response. 0.93. What is the ratio of the Rating (1=low 6=high) in Public resource use in 2008 to that in 2011?
Your response must be concise. 0.96. What is the ratio of the Rating (1=low 6=high) of Macroeconomic management in 2008 to that in 2011?
Give a very brief answer. 0.98. What is the ratio of the Rating (1=low 6=high) in Rule based governance in 2008 to that in 2011?
Give a very brief answer. 0.95. What is the ratio of the Rating (1=low 6=high) in Revenue mobilization in 2008 to that in 2012?
Your answer should be compact. 0.95. What is the ratio of the Rating (1=low 6=high) in Public resource use in 2008 to that in 2012?
Your answer should be very brief. 0.97. What is the ratio of the Rating (1=low 6=high) of Rule based governance in 2008 to that in 2012?
Offer a terse response. 0.96. What is the ratio of the Rating (1=low 6=high) of Revenue mobilization in 2009 to that in 2010?
Provide a short and direct response. 0.96. What is the ratio of the Rating (1=low 6=high) in Public resource use in 2009 to that in 2010?
Offer a very short reply. 0.96. What is the ratio of the Rating (1=low 6=high) of Macroeconomic management in 2009 to that in 2010?
Ensure brevity in your answer.  1.01. What is the ratio of the Rating (1=low 6=high) in Rule based governance in 2009 to that in 2010?
Offer a terse response. 0.99. What is the ratio of the Rating (1=low 6=high) in Revenue mobilization in 2009 to that in 2011?
Make the answer very short. 0.98. What is the ratio of the Rating (1=low 6=high) in Public resource use in 2009 to that in 2011?
Provide a succinct answer. 1.01. What is the ratio of the Rating (1=low 6=high) of Rule based governance in 2009 to that in 2011?
Make the answer very short. 0.95. What is the ratio of the Rating (1=low 6=high) of Macroeconomic management in 2009 to that in 2012?
Make the answer very short. 1.01. What is the ratio of the Rating (1=low 6=high) in Rule based governance in 2009 to that in 2012?
Make the answer very short. 0.96. What is the ratio of the Rating (1=low 6=high) in Revenue mobilization in 2010 to that in 2011?
Provide a short and direct response. 1.02. What is the ratio of the Rating (1=low 6=high) of Public resource use in 2010 to that in 2011?
Give a very brief answer. 1.05. What is the ratio of the Rating (1=low 6=high) of Macroeconomic management in 2010 to that in 2011?
Provide a short and direct response. 0.98. What is the ratio of the Rating (1=low 6=high) in Rule based governance in 2010 to that in 2011?
Your response must be concise. 0.97. What is the ratio of the Rating (1=low 6=high) of Revenue mobilization in 2010 to that in 2012?
Make the answer very short. 1.04. What is the ratio of the Rating (1=low 6=high) of Public resource use in 2010 to that in 2012?
Provide a succinct answer. 1.06. What is the ratio of the Rating (1=low 6=high) of Rule based governance in 2010 to that in 2012?
Offer a very short reply. 0.97. What is the ratio of the Rating (1=low 6=high) in Revenue mobilization in 2011 to that in 2012?
Give a very brief answer. 1.02. What is the ratio of the Rating (1=low 6=high) in Public resource use in 2011 to that in 2012?
Provide a succinct answer. 1.01. What is the ratio of the Rating (1=low 6=high) of Macroeconomic management in 2011 to that in 2012?
Offer a very short reply. 1.01. What is the difference between the highest and the second highest Rating (1=low 6=high) of Revenue mobilization?
Your response must be concise. 0.08. What is the difference between the highest and the second highest Rating (1=low 6=high) of Public resource use?
Your answer should be very brief. 0.14. What is the difference between the highest and the second highest Rating (1=low 6=high) of Macroeconomic management?
Give a very brief answer. 0.04. What is the difference between the highest and the second highest Rating (1=low 6=high) of Rule based governance?
Your response must be concise. 0.01. What is the difference between the highest and the lowest Rating (1=low 6=high) in Revenue mobilization?
Keep it short and to the point. 0.36. What is the difference between the highest and the lowest Rating (1=low 6=high) of Public resource use?
Provide a short and direct response. 0.32. What is the difference between the highest and the lowest Rating (1=low 6=high) in Macroeconomic management?
Keep it short and to the point. 0.09. What is the difference between the highest and the lowest Rating (1=low 6=high) of Rule based governance?
Provide a succinct answer. 0.28. 